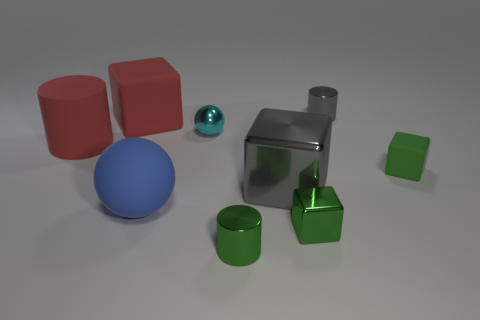Subtract all gray blocks. How many blocks are left? 3 Subtract 1 blocks. How many blocks are left? 3 Subtract all tiny metallic cylinders. How many cylinders are left? 1 Add 1 big red rubber things. How many objects exist? 10 Subtract all cyan blocks. Subtract all yellow balls. How many blocks are left? 4 Subtract all cylinders. How many objects are left? 6 Add 3 gray cylinders. How many gray cylinders exist? 4 Subtract 0 blue cylinders. How many objects are left? 9 Subtract all objects. Subtract all small yellow cylinders. How many objects are left? 0 Add 6 big blue balls. How many big blue balls are left? 7 